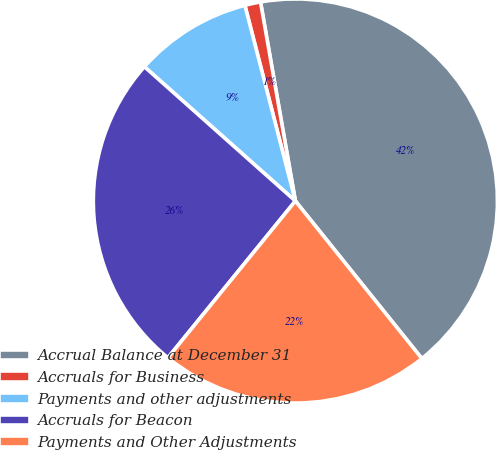<chart> <loc_0><loc_0><loc_500><loc_500><pie_chart><fcel>Accrual Balance at December 31<fcel>Accruals for Business<fcel>Payments and other adjustments<fcel>Accruals for Beacon<fcel>Payments and Other Adjustments<nl><fcel>41.99%<fcel>1.26%<fcel>9.41%<fcel>25.7%<fcel>21.63%<nl></chart> 